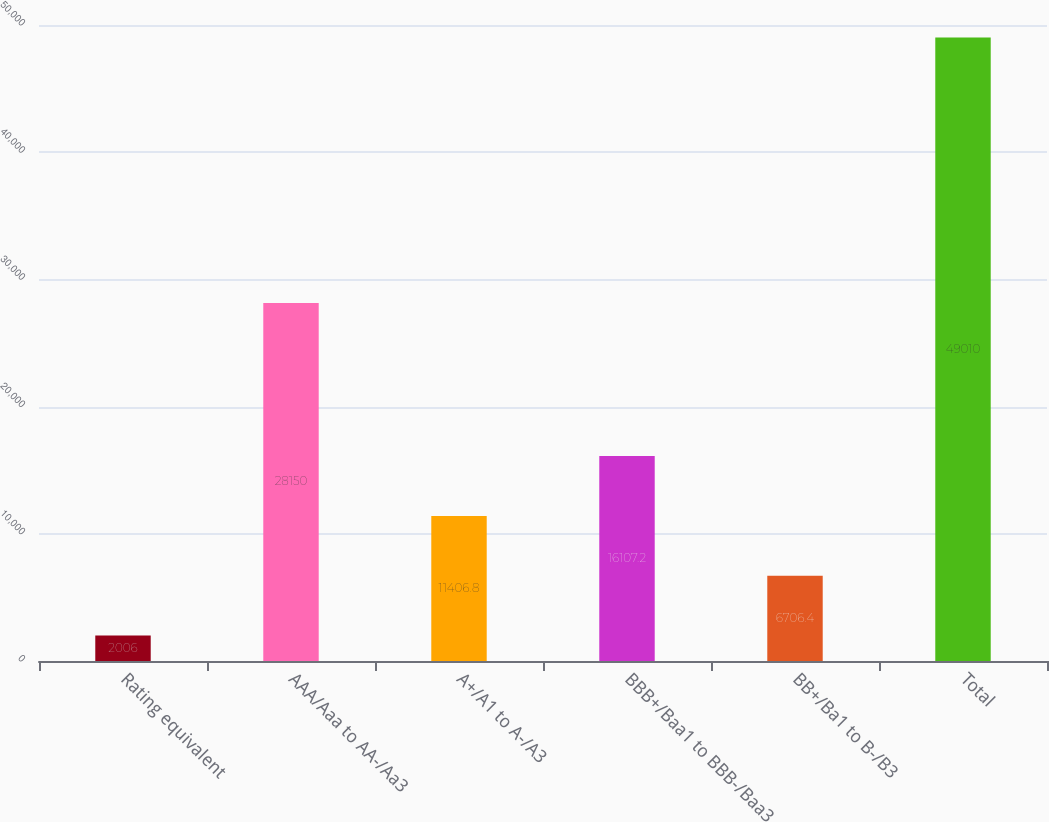Convert chart to OTSL. <chart><loc_0><loc_0><loc_500><loc_500><bar_chart><fcel>Rating equivalent<fcel>AAA/Aaa to AA-/Aa3<fcel>A+/A1 to A-/A3<fcel>BBB+/Baa1 to BBB-/Baa3<fcel>BB+/Ba1 to B-/B3<fcel>Total<nl><fcel>2006<fcel>28150<fcel>11406.8<fcel>16107.2<fcel>6706.4<fcel>49010<nl></chart> 